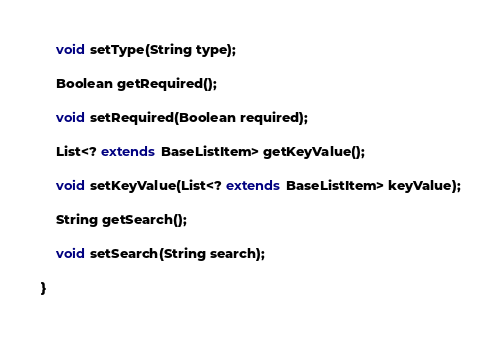<code> <loc_0><loc_0><loc_500><loc_500><_Java_>    void setType(String type);

    Boolean getRequired();

    void setRequired(Boolean required);

    List<? extends BaseListItem> getKeyValue();

    void setKeyValue(List<? extends BaseListItem> keyValue);

    String getSearch();

    void setSearch(String search);

}
</code> 